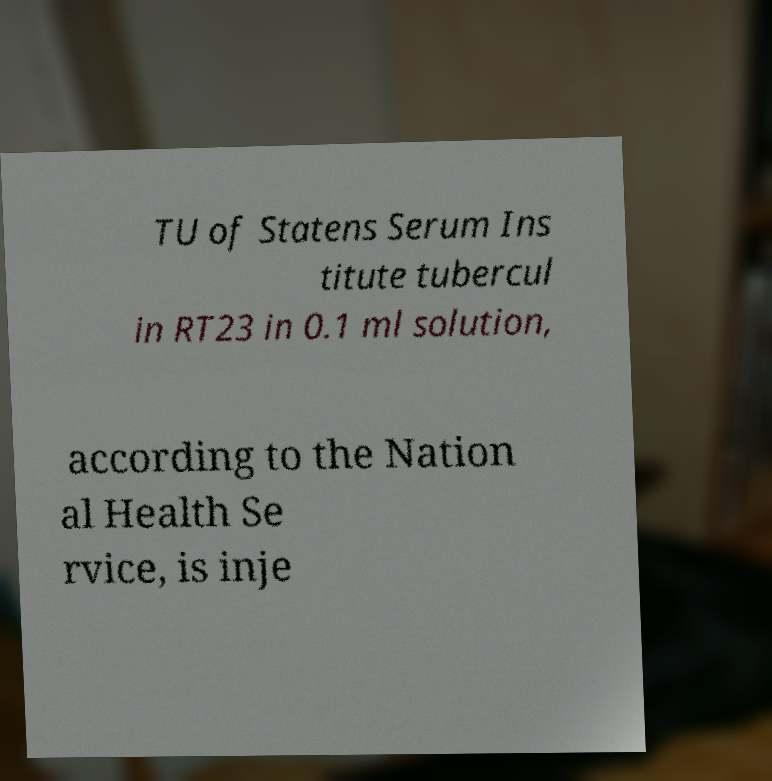I need the written content from this picture converted into text. Can you do that? TU of Statens Serum Ins titute tubercul in RT23 in 0.1 ml solution, according to the Nation al Health Se rvice, is inje 